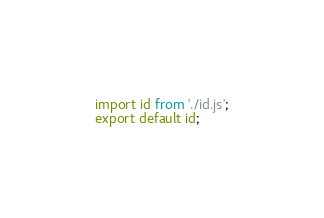<code> <loc_0><loc_0><loc_500><loc_500><_JavaScript_>import id from './id.js';
export default id;
</code> 